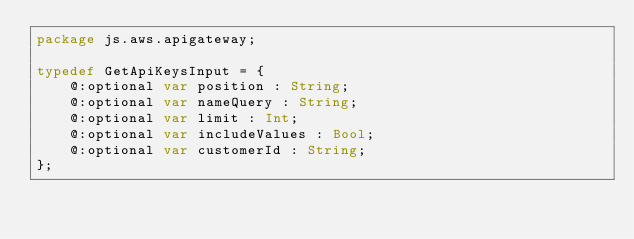<code> <loc_0><loc_0><loc_500><loc_500><_Haxe_>package js.aws.apigateway;

typedef GetApiKeysInput = {
    @:optional var position : String;
    @:optional var nameQuery : String;
    @:optional var limit : Int;
    @:optional var includeValues : Bool;
    @:optional var customerId : String;
};
</code> 